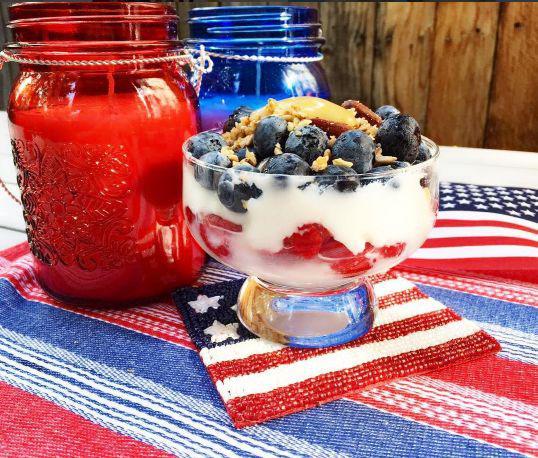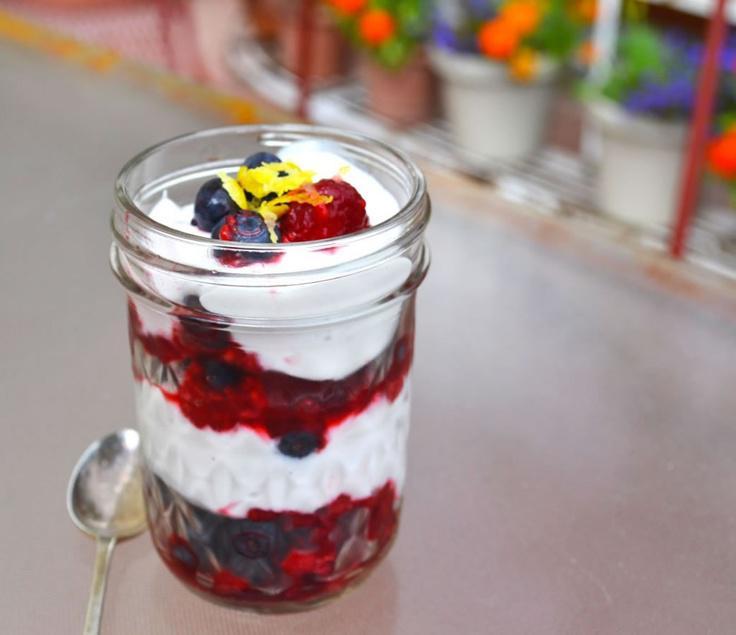The first image is the image on the left, the second image is the image on the right. Evaluate the accuracy of this statement regarding the images: "There is exactly one dessert in an open jar in one of the images". Is it true? Answer yes or no. Yes. 